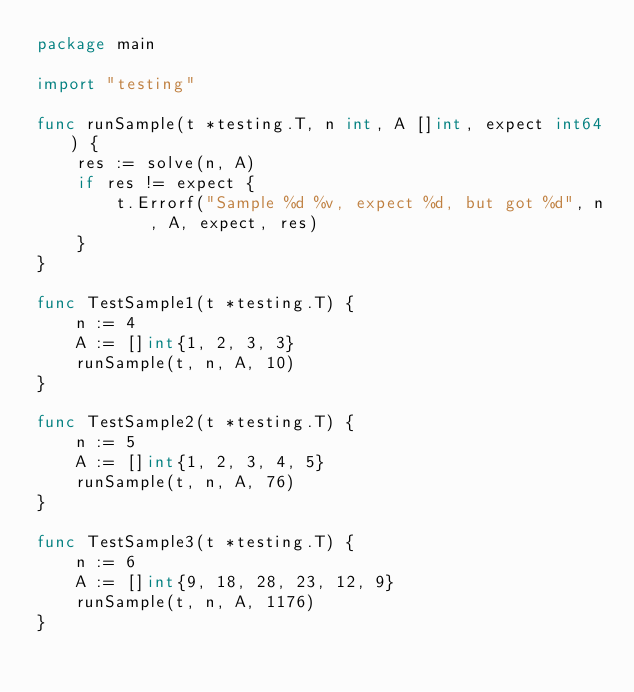<code> <loc_0><loc_0><loc_500><loc_500><_Go_>package main

import "testing"

func runSample(t *testing.T, n int, A []int, expect int64) {
	res := solve(n, A)
	if res != expect {
		t.Errorf("Sample %d %v, expect %d, but got %d", n, A, expect, res)
	}
}

func TestSample1(t *testing.T) {
	n := 4
	A := []int{1, 2, 3, 3}
	runSample(t, n, A, 10)
}

func TestSample2(t *testing.T) {
	n := 5
	A := []int{1, 2, 3, 4, 5}
	runSample(t, n, A, 76)
}

func TestSample3(t *testing.T) {
	n := 6
	A := []int{9, 18, 28, 23, 12, 9}
	runSample(t, n, A, 1176)
}
</code> 